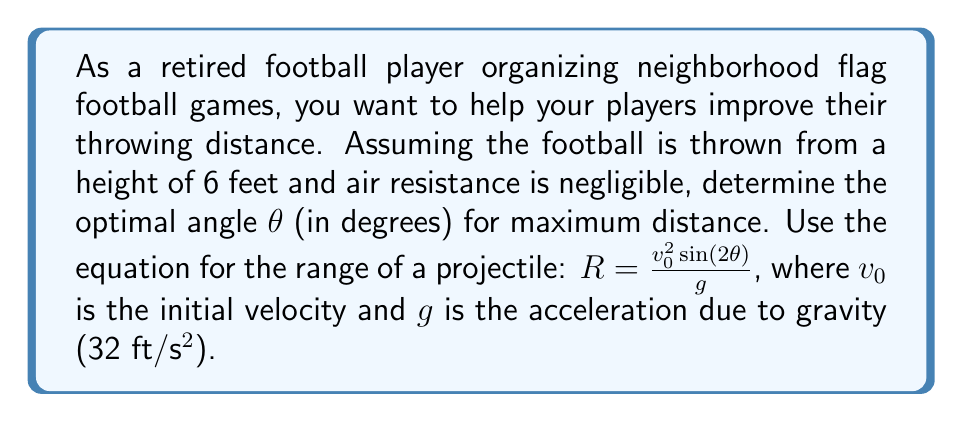Could you help me with this problem? To find the optimal angle for maximum distance, we need to maximize the range equation:

$R = \frac{v_0^2 \sin(2\theta)}{g}$

The only variable in this equation that we can change is θ, so we need to find the value of θ that maximizes $\sin(2\theta)$.

The sine function reaches its maximum value of 1 when its argument is 90°. Therefore:

$2\theta = 90°$

Solving for θ:

$\theta = 45°$

This result is independent of the initial velocity and the acceleration due to gravity, making it universally applicable for projectile motion without air resistance.

Note: In reality, factors such as air resistance and the initial height of the throw (6 feet in this case) would slightly alter the optimal angle. Typically, these factors reduce the optimal angle to around 42-43 degrees. However, for the purposes of this idealized problem, we consider the 45-degree angle as optimal.

[asy]
import graph;
size(200,200);
real f(real x) {return -x^2/50+6;}
draw(graph(f,0,10));
draw((0,0)--(10,0),arrow=Arrow(TeXHead));
draw((0,0)--(0,8),arrow=Arrow(TeXHead));
label("Distance",((10,0)),S);
label("Height",(0,8),W);
draw((0,6)--(5,8.5),arrow=Arrow(TeXHead));
label("45°",(2,6.5),NE);
dot((0,6));
label("6 ft",(0,6),W);
[/asy]
Answer: The optimal angle for maximum distance in a football throw, under ideal conditions, is 45°. 